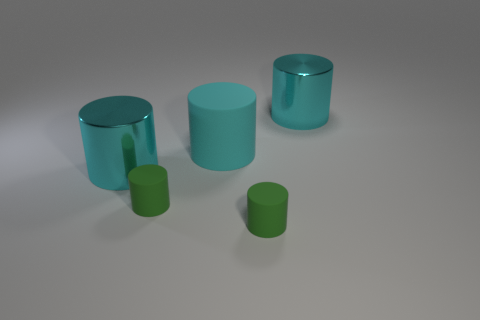Subtract all purple cubes. How many cyan cylinders are left? 3 Subtract all cyan matte cylinders. How many cylinders are left? 4 Subtract all yellow cylinders. Subtract all green spheres. How many cylinders are left? 5 Add 1 cyan cylinders. How many objects exist? 6 Subtract 0 blue balls. How many objects are left? 5 Subtract all metallic cylinders. Subtract all small green rubber objects. How many objects are left? 1 Add 3 big cyan shiny cylinders. How many big cyan shiny cylinders are left? 5 Add 2 large cyan rubber cylinders. How many large cyan rubber cylinders exist? 3 